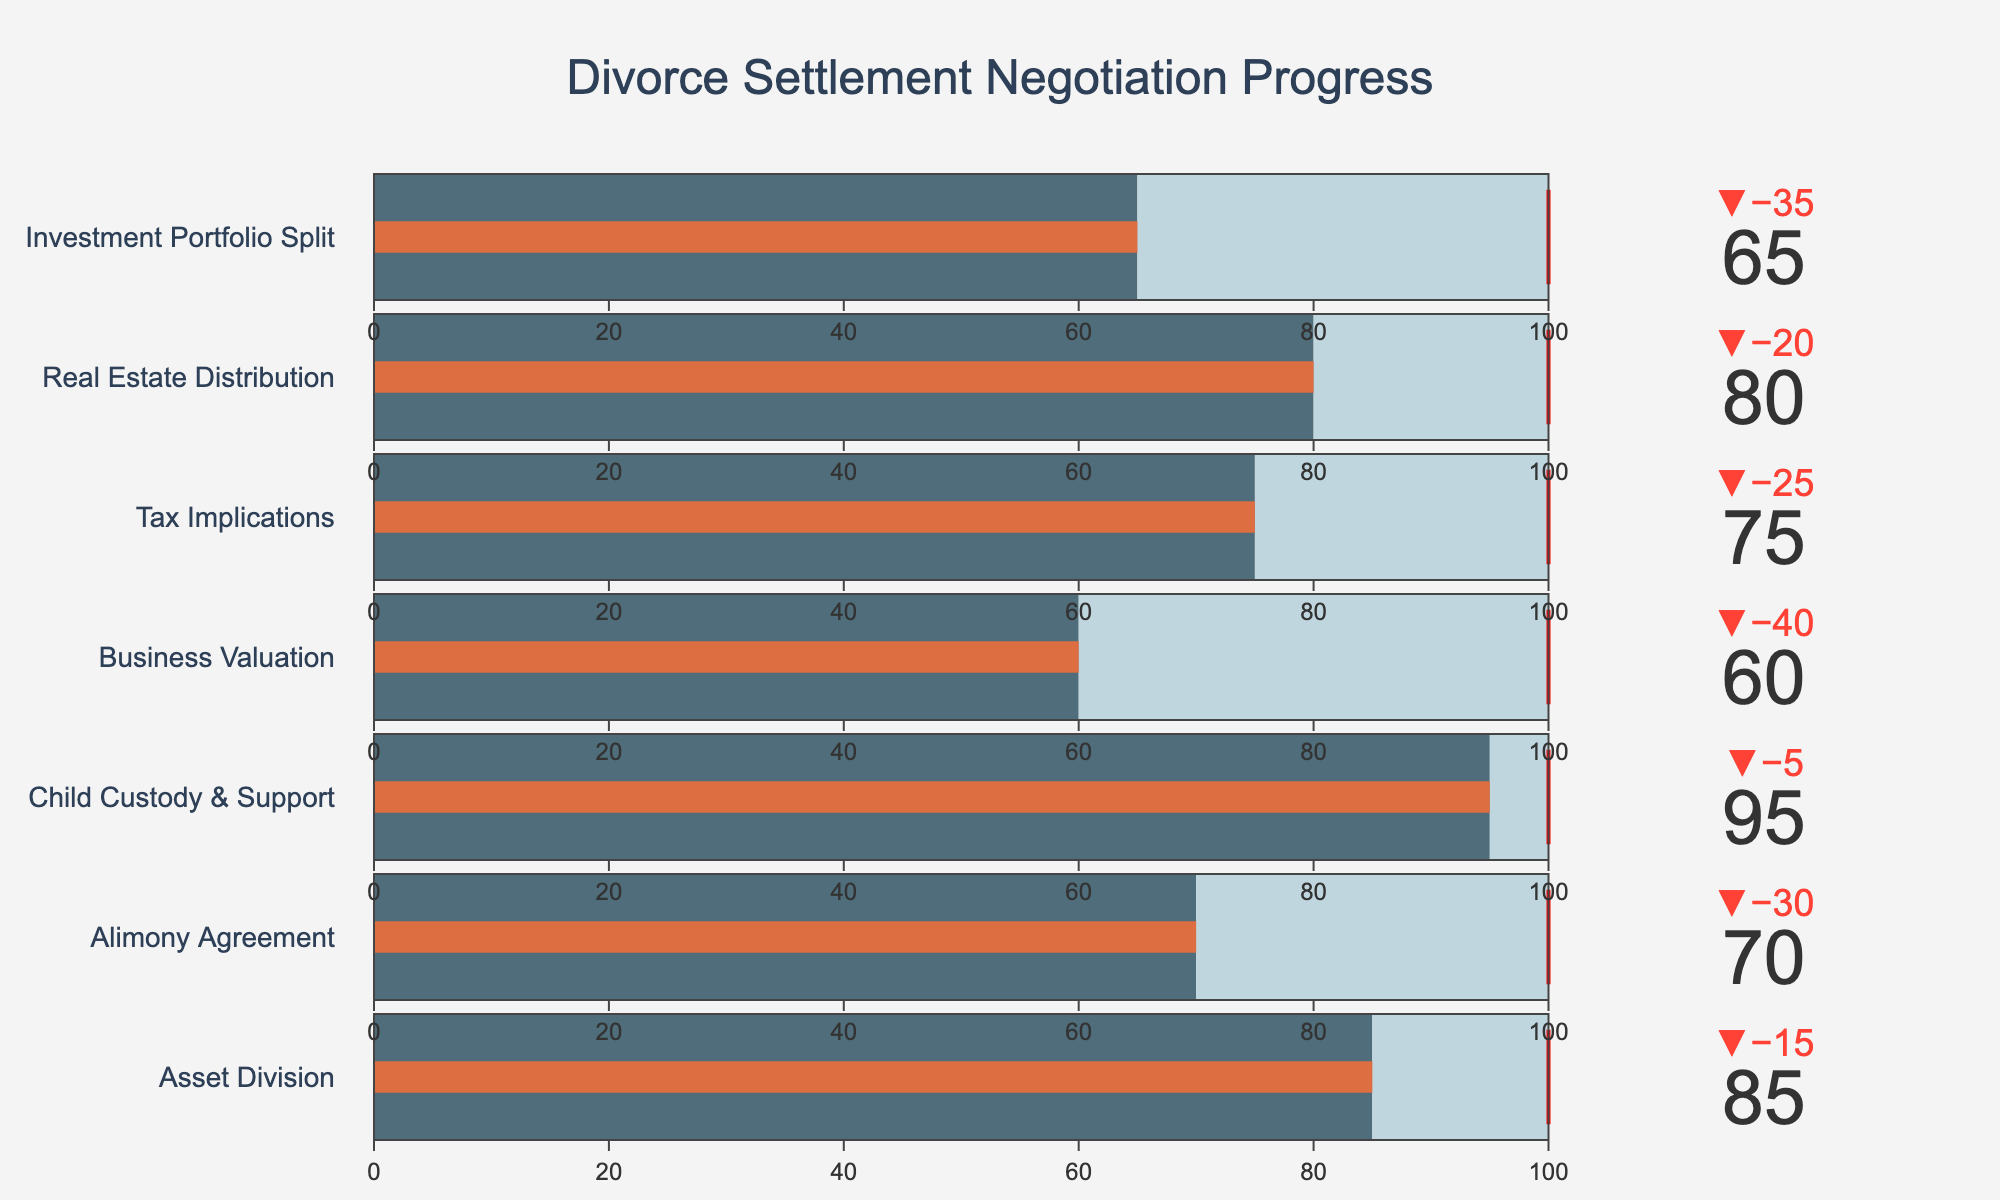what is the title of the figure? The title of the figure is displayed at the top of the chart and is clearly larger and more prominent than other text elements.
Answer: Divorce Settlement Negotiation Progress What is the percentage target for the Alimony Agreement category? The target value for each category is shown using a red threshold line on the bullet chart. In the "Alimony Agreement" category, the target line is positioned at the 100% mark.
Answer: 100% Which category has the highest percentage of completion? By visually inspecting the bullet chart, we can see the bar that reaches the highest value. The "Child Custody & Support" category has the highest percentage of completion at 95%.
Answer: Child Custody & Support What is the value of the threshold line for the Business Valuation category? The threshold line, marked in red on the bullet chart, indicates the target percentage. In the "Business Valuation" category, this line is positioned at 100%.
Answer: 100% What is the difference between the actual and target values for the Investment Portfolio Split category? The actual value for the "Investment Portfolio Split" category is 65% and the target value is 100%. The difference can be calculated simply as 100% - 65% = 35%.
Answer: 35% Order these categories from highest to lowest completion percentage. We need to list the categories based on their actual completion percentages from highest to lowest: Child Custody & Support (95%), Asset Division (85%), Real Estate Distribution (80%), Tax Implications (75%), Alimony Agreement (70%), Investment Portfolio Split (65%), Business Valuation (60%).
Answer: Child Custody & Support, Asset Division, Real Estate Distribution, Tax Implications, Alimony Agreement, Investment Portfolio Split, Business Valuation What's the average completion percentage across all categories? To determine the average, sum the actual completion values of all categories and divide by the number of categories: (85 + 70 + 95 + 60 + 75 + 80 + 65) / 7 = 75.71 (rounded to two decimal places).
Answer: 75.71 How many categories have completion percentages below 70%? By examining the bullet chart, we identify the categories with actual values below 70%: Alimony Agreement (70%), Business Valuation (60%), and Investment Portfolio Split (65%). There are 3 such categories.
Answer: 3 In which category is the actual value furthest from the target value? We need to calculate the absolute differences between actual and target values for each category. "Business Valuation" has the largest absolute difference: 100% - 60% = 40%.
Answer: Business Valuation 